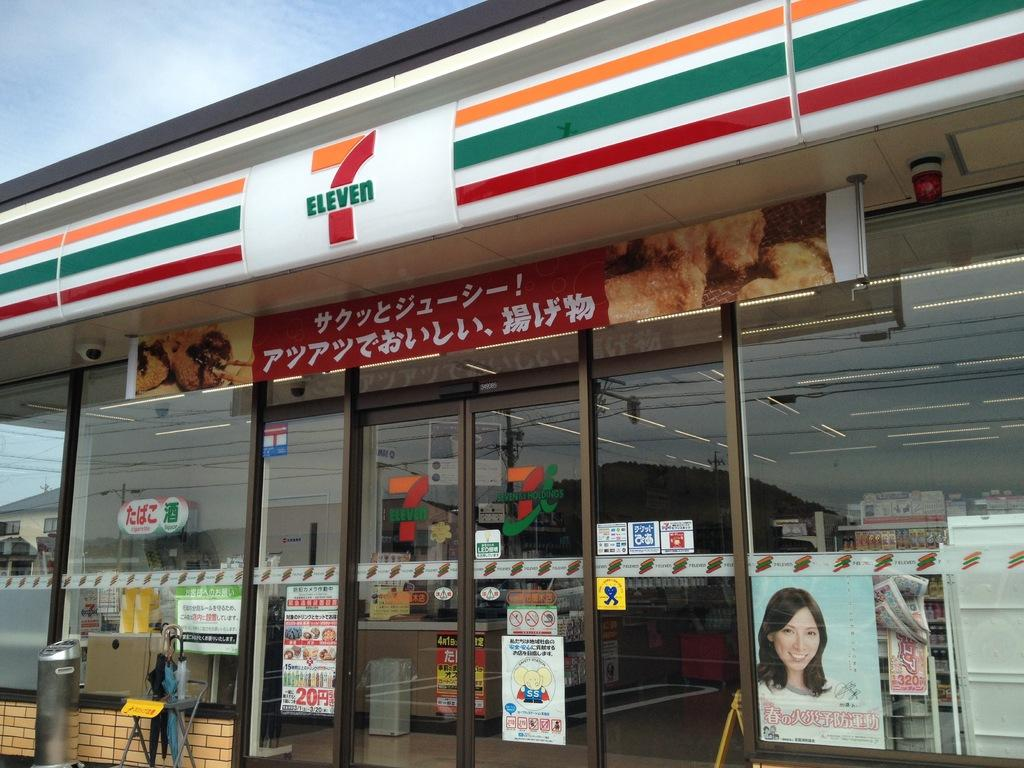Provide a one-sentence caption for the provided image. A 7 Eleven store in Japan has banners advertising their products on the windows. 